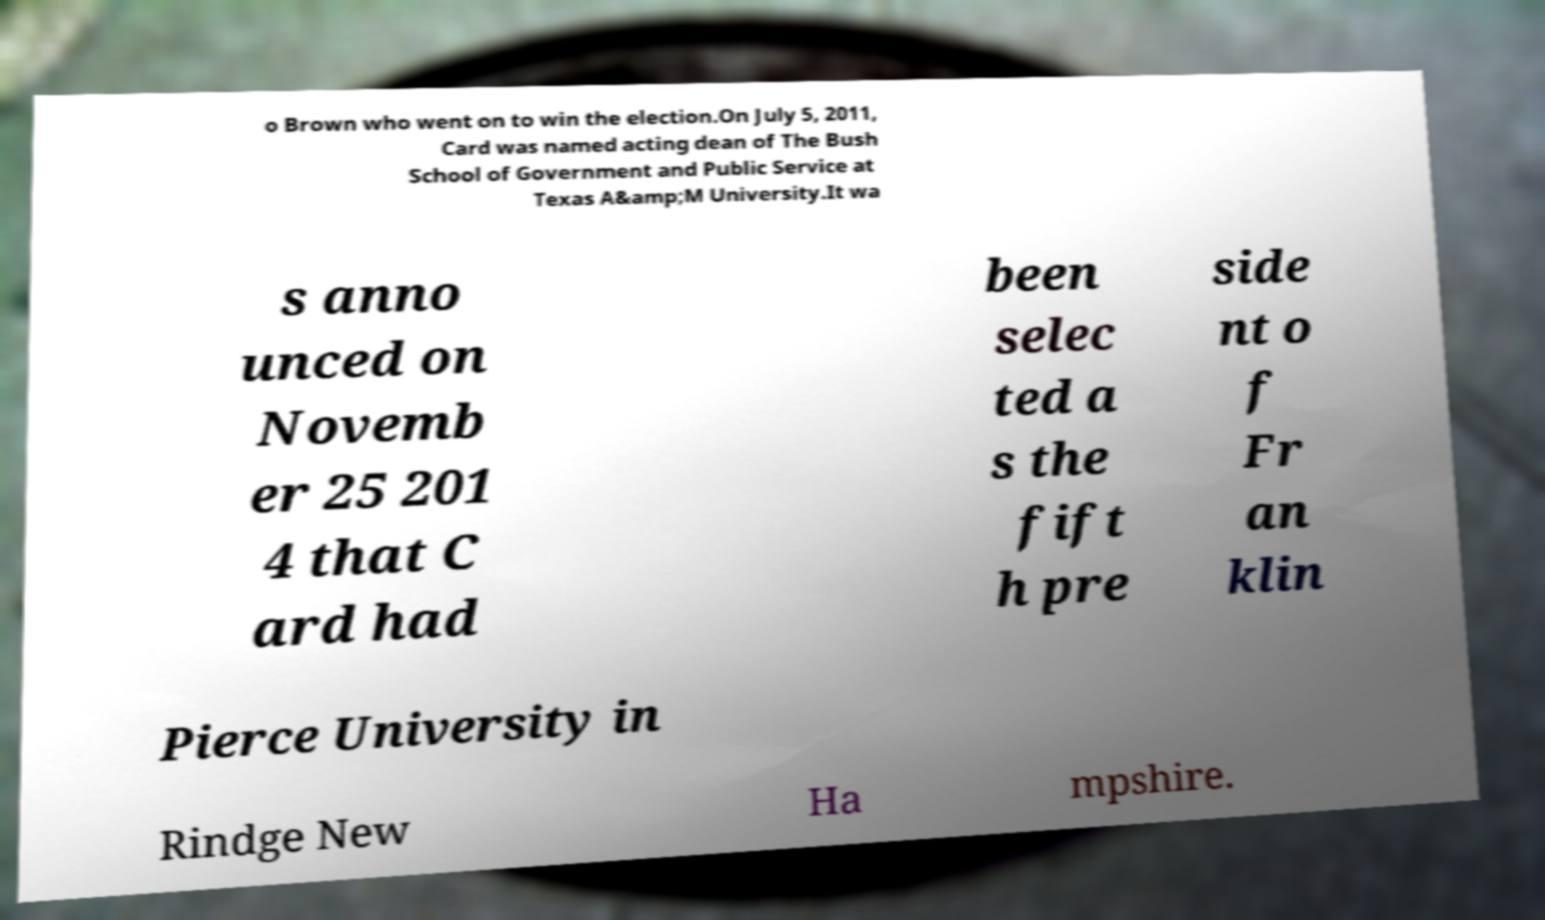What messages or text are displayed in this image? I need them in a readable, typed format. o Brown who went on to win the election.On July 5, 2011, Card was named acting dean of The Bush School of Government and Public Service at Texas A&amp;M University.It wa s anno unced on Novemb er 25 201 4 that C ard had been selec ted a s the fift h pre side nt o f Fr an klin Pierce University in Rindge New Ha mpshire. 